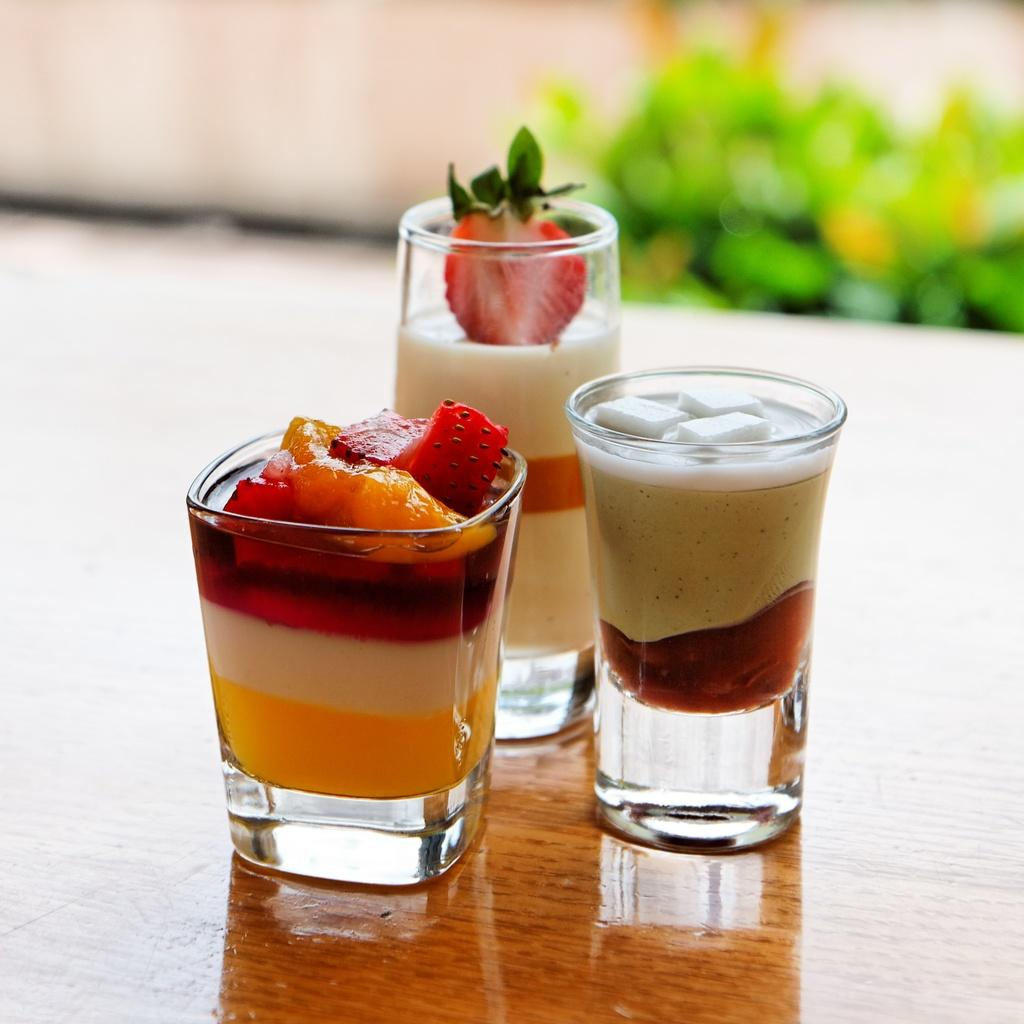How many glasses are visible in the image? There are three glasses in the image. What is inside the glasses? The glasses contain liquids and fruits. On what surface are the glasses placed? The glasses are placed on a wooden surface. What can be seen in the background of the image? The background of the image is blurred, and plants are present. What type of pen is used to draw the plants in the background? There is no pen or drawing present in the image; the plants are real and visible in the background. 